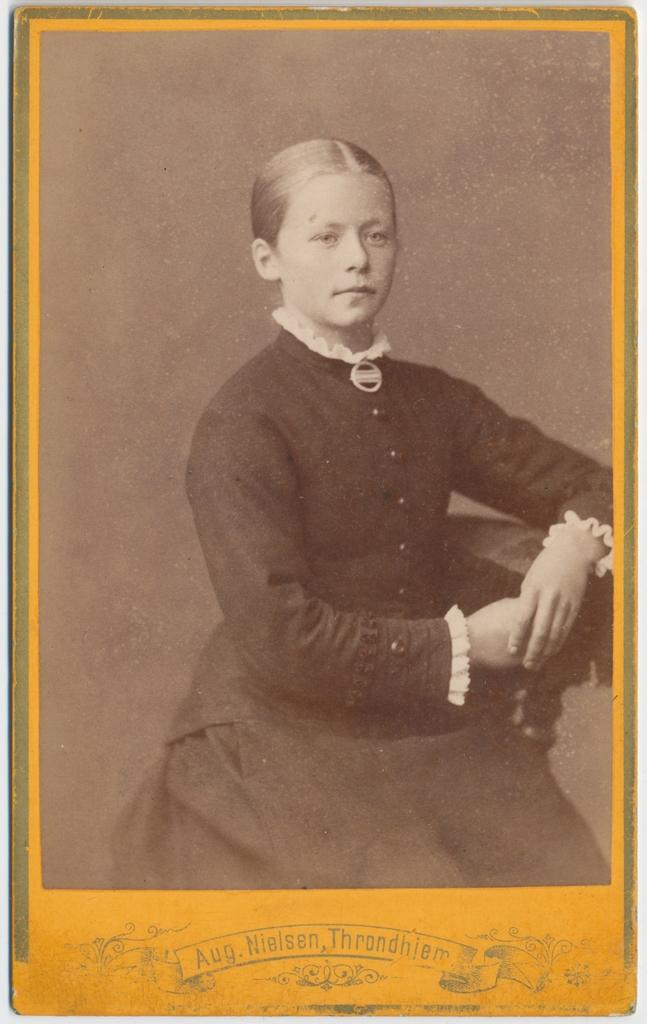What is the main subject of the image? There is a person in the image. What is the person doing in the image? The person is posing for a camera. Are there any words or letters in the image? Yes, there are letters at the bottom portion of the image. Can you tell me what type of kite the person is holding in the image? There is no kite present in the image; the person is posing for a camera. Is there an uncle in the image? The provided facts do not mention an uncle, so we cannot determine if there is an uncle in the image. 